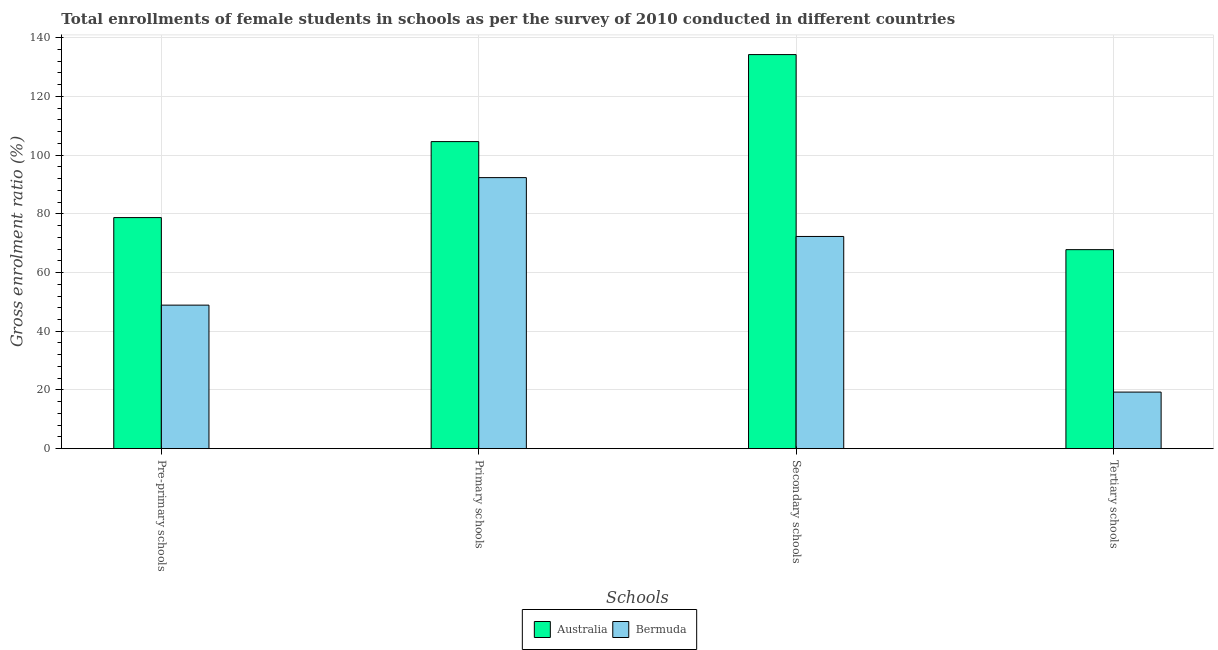How many different coloured bars are there?
Your answer should be very brief. 2. Are the number of bars per tick equal to the number of legend labels?
Provide a short and direct response. Yes. How many bars are there on the 1st tick from the right?
Make the answer very short. 2. What is the label of the 3rd group of bars from the left?
Your response must be concise. Secondary schools. What is the gross enrolment ratio(female) in secondary schools in Bermuda?
Provide a short and direct response. 72.29. Across all countries, what is the maximum gross enrolment ratio(female) in tertiary schools?
Your answer should be very brief. 67.8. Across all countries, what is the minimum gross enrolment ratio(female) in tertiary schools?
Keep it short and to the point. 19.28. In which country was the gross enrolment ratio(female) in primary schools minimum?
Provide a short and direct response. Bermuda. What is the total gross enrolment ratio(female) in tertiary schools in the graph?
Provide a short and direct response. 87.07. What is the difference between the gross enrolment ratio(female) in primary schools in Bermuda and that in Australia?
Provide a succinct answer. -12.27. What is the difference between the gross enrolment ratio(female) in pre-primary schools in Australia and the gross enrolment ratio(female) in primary schools in Bermuda?
Your response must be concise. -13.61. What is the average gross enrolment ratio(female) in tertiary schools per country?
Your response must be concise. 43.54. What is the difference between the gross enrolment ratio(female) in primary schools and gross enrolment ratio(female) in tertiary schools in Bermuda?
Offer a terse response. 73.05. What is the ratio of the gross enrolment ratio(female) in primary schools in Australia to that in Bermuda?
Make the answer very short. 1.13. Is the difference between the gross enrolment ratio(female) in primary schools in Bermuda and Australia greater than the difference between the gross enrolment ratio(female) in secondary schools in Bermuda and Australia?
Your answer should be very brief. Yes. What is the difference between the highest and the second highest gross enrolment ratio(female) in tertiary schools?
Ensure brevity in your answer.  48.52. What is the difference between the highest and the lowest gross enrolment ratio(female) in primary schools?
Your response must be concise. 12.27. In how many countries, is the gross enrolment ratio(female) in pre-primary schools greater than the average gross enrolment ratio(female) in pre-primary schools taken over all countries?
Your response must be concise. 1. Is the sum of the gross enrolment ratio(female) in primary schools in Bermuda and Australia greater than the maximum gross enrolment ratio(female) in secondary schools across all countries?
Ensure brevity in your answer.  Yes. What does the 1st bar from the right in Secondary schools represents?
Ensure brevity in your answer.  Bermuda. How many bars are there?
Keep it short and to the point. 8. Are all the bars in the graph horizontal?
Provide a succinct answer. No. How many countries are there in the graph?
Offer a very short reply. 2. Does the graph contain grids?
Make the answer very short. Yes. How many legend labels are there?
Your answer should be compact. 2. How are the legend labels stacked?
Your answer should be very brief. Horizontal. What is the title of the graph?
Ensure brevity in your answer.  Total enrollments of female students in schools as per the survey of 2010 conducted in different countries. What is the label or title of the X-axis?
Provide a short and direct response. Schools. What is the label or title of the Y-axis?
Your response must be concise. Gross enrolment ratio (%). What is the Gross enrolment ratio (%) of Australia in Pre-primary schools?
Offer a terse response. 78.72. What is the Gross enrolment ratio (%) in Bermuda in Pre-primary schools?
Make the answer very short. 48.89. What is the Gross enrolment ratio (%) in Australia in Primary schools?
Ensure brevity in your answer.  104.6. What is the Gross enrolment ratio (%) of Bermuda in Primary schools?
Make the answer very short. 92.33. What is the Gross enrolment ratio (%) in Australia in Secondary schools?
Offer a very short reply. 134.24. What is the Gross enrolment ratio (%) in Bermuda in Secondary schools?
Offer a very short reply. 72.29. What is the Gross enrolment ratio (%) in Australia in Tertiary schools?
Make the answer very short. 67.8. What is the Gross enrolment ratio (%) of Bermuda in Tertiary schools?
Ensure brevity in your answer.  19.28. Across all Schools, what is the maximum Gross enrolment ratio (%) in Australia?
Give a very brief answer. 134.24. Across all Schools, what is the maximum Gross enrolment ratio (%) in Bermuda?
Provide a short and direct response. 92.33. Across all Schools, what is the minimum Gross enrolment ratio (%) in Australia?
Ensure brevity in your answer.  67.8. Across all Schools, what is the minimum Gross enrolment ratio (%) in Bermuda?
Offer a terse response. 19.28. What is the total Gross enrolment ratio (%) of Australia in the graph?
Provide a short and direct response. 385.36. What is the total Gross enrolment ratio (%) of Bermuda in the graph?
Keep it short and to the point. 232.79. What is the difference between the Gross enrolment ratio (%) in Australia in Pre-primary schools and that in Primary schools?
Your answer should be compact. -25.89. What is the difference between the Gross enrolment ratio (%) of Bermuda in Pre-primary schools and that in Primary schools?
Your answer should be compact. -43.44. What is the difference between the Gross enrolment ratio (%) in Australia in Pre-primary schools and that in Secondary schools?
Provide a short and direct response. -55.53. What is the difference between the Gross enrolment ratio (%) in Bermuda in Pre-primary schools and that in Secondary schools?
Give a very brief answer. -23.39. What is the difference between the Gross enrolment ratio (%) of Australia in Pre-primary schools and that in Tertiary schools?
Give a very brief answer. 10.92. What is the difference between the Gross enrolment ratio (%) of Bermuda in Pre-primary schools and that in Tertiary schools?
Keep it short and to the point. 29.62. What is the difference between the Gross enrolment ratio (%) in Australia in Primary schools and that in Secondary schools?
Make the answer very short. -29.64. What is the difference between the Gross enrolment ratio (%) of Bermuda in Primary schools and that in Secondary schools?
Provide a succinct answer. 20.04. What is the difference between the Gross enrolment ratio (%) in Australia in Primary schools and that in Tertiary schools?
Offer a very short reply. 36.8. What is the difference between the Gross enrolment ratio (%) in Bermuda in Primary schools and that in Tertiary schools?
Provide a succinct answer. 73.05. What is the difference between the Gross enrolment ratio (%) in Australia in Secondary schools and that in Tertiary schools?
Keep it short and to the point. 66.44. What is the difference between the Gross enrolment ratio (%) of Bermuda in Secondary schools and that in Tertiary schools?
Offer a very short reply. 53.01. What is the difference between the Gross enrolment ratio (%) of Australia in Pre-primary schools and the Gross enrolment ratio (%) of Bermuda in Primary schools?
Offer a very short reply. -13.61. What is the difference between the Gross enrolment ratio (%) of Australia in Pre-primary schools and the Gross enrolment ratio (%) of Bermuda in Secondary schools?
Offer a terse response. 6.43. What is the difference between the Gross enrolment ratio (%) in Australia in Pre-primary schools and the Gross enrolment ratio (%) in Bermuda in Tertiary schools?
Your answer should be compact. 59.44. What is the difference between the Gross enrolment ratio (%) of Australia in Primary schools and the Gross enrolment ratio (%) of Bermuda in Secondary schools?
Provide a short and direct response. 32.31. What is the difference between the Gross enrolment ratio (%) of Australia in Primary schools and the Gross enrolment ratio (%) of Bermuda in Tertiary schools?
Provide a succinct answer. 85.33. What is the difference between the Gross enrolment ratio (%) of Australia in Secondary schools and the Gross enrolment ratio (%) of Bermuda in Tertiary schools?
Your answer should be compact. 114.97. What is the average Gross enrolment ratio (%) of Australia per Schools?
Offer a very short reply. 96.34. What is the average Gross enrolment ratio (%) of Bermuda per Schools?
Provide a short and direct response. 58.2. What is the difference between the Gross enrolment ratio (%) of Australia and Gross enrolment ratio (%) of Bermuda in Pre-primary schools?
Offer a very short reply. 29.82. What is the difference between the Gross enrolment ratio (%) in Australia and Gross enrolment ratio (%) in Bermuda in Primary schools?
Give a very brief answer. 12.27. What is the difference between the Gross enrolment ratio (%) of Australia and Gross enrolment ratio (%) of Bermuda in Secondary schools?
Provide a succinct answer. 61.95. What is the difference between the Gross enrolment ratio (%) of Australia and Gross enrolment ratio (%) of Bermuda in Tertiary schools?
Keep it short and to the point. 48.52. What is the ratio of the Gross enrolment ratio (%) of Australia in Pre-primary schools to that in Primary schools?
Provide a short and direct response. 0.75. What is the ratio of the Gross enrolment ratio (%) in Bermuda in Pre-primary schools to that in Primary schools?
Offer a terse response. 0.53. What is the ratio of the Gross enrolment ratio (%) of Australia in Pre-primary schools to that in Secondary schools?
Your response must be concise. 0.59. What is the ratio of the Gross enrolment ratio (%) in Bermuda in Pre-primary schools to that in Secondary schools?
Offer a very short reply. 0.68. What is the ratio of the Gross enrolment ratio (%) of Australia in Pre-primary schools to that in Tertiary schools?
Keep it short and to the point. 1.16. What is the ratio of the Gross enrolment ratio (%) in Bermuda in Pre-primary schools to that in Tertiary schools?
Offer a terse response. 2.54. What is the ratio of the Gross enrolment ratio (%) of Australia in Primary schools to that in Secondary schools?
Offer a very short reply. 0.78. What is the ratio of the Gross enrolment ratio (%) in Bermuda in Primary schools to that in Secondary schools?
Provide a short and direct response. 1.28. What is the ratio of the Gross enrolment ratio (%) of Australia in Primary schools to that in Tertiary schools?
Make the answer very short. 1.54. What is the ratio of the Gross enrolment ratio (%) in Bermuda in Primary schools to that in Tertiary schools?
Give a very brief answer. 4.79. What is the ratio of the Gross enrolment ratio (%) of Australia in Secondary schools to that in Tertiary schools?
Your response must be concise. 1.98. What is the ratio of the Gross enrolment ratio (%) of Bermuda in Secondary schools to that in Tertiary schools?
Provide a short and direct response. 3.75. What is the difference between the highest and the second highest Gross enrolment ratio (%) of Australia?
Your response must be concise. 29.64. What is the difference between the highest and the second highest Gross enrolment ratio (%) of Bermuda?
Your response must be concise. 20.04. What is the difference between the highest and the lowest Gross enrolment ratio (%) of Australia?
Your answer should be compact. 66.44. What is the difference between the highest and the lowest Gross enrolment ratio (%) in Bermuda?
Provide a succinct answer. 73.05. 